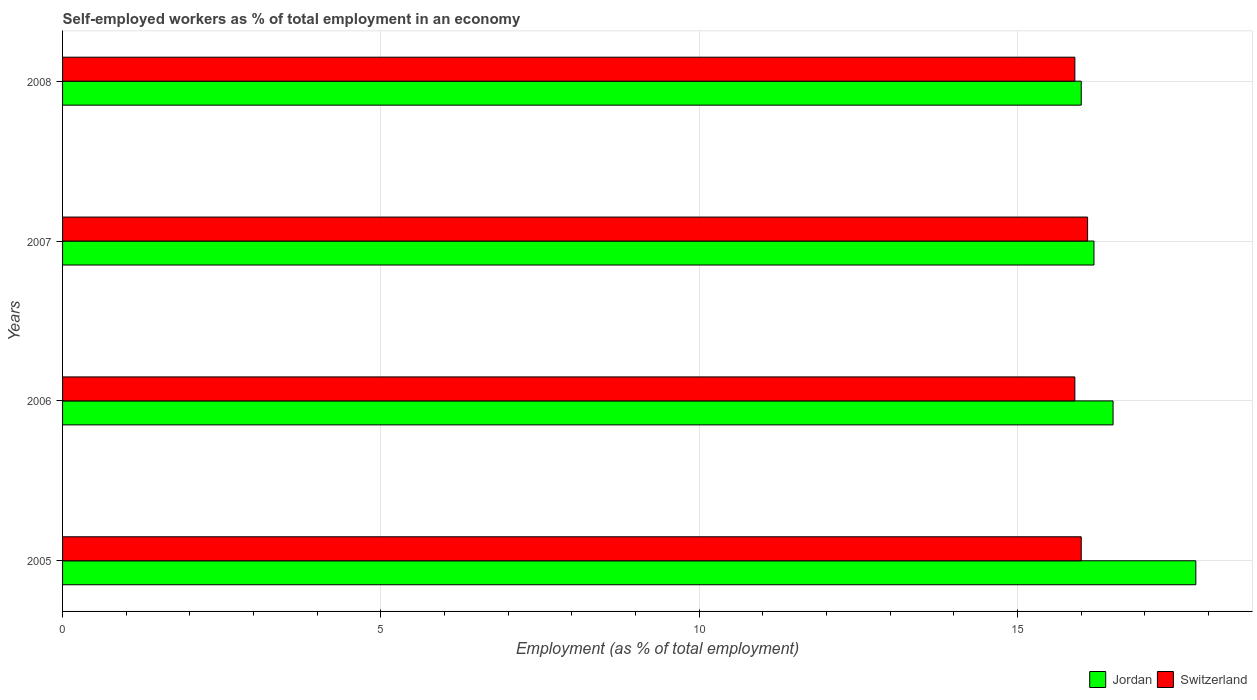Are the number of bars per tick equal to the number of legend labels?
Your response must be concise. Yes. Are the number of bars on each tick of the Y-axis equal?
Your answer should be very brief. Yes. How many bars are there on the 2nd tick from the top?
Your answer should be compact. 2. How many bars are there on the 3rd tick from the bottom?
Provide a short and direct response. 2. What is the percentage of self-employed workers in Switzerland in 2006?
Your answer should be compact. 15.9. Across all years, what is the maximum percentage of self-employed workers in Switzerland?
Keep it short and to the point. 16.1. In which year was the percentage of self-employed workers in Jordan maximum?
Offer a terse response. 2005. What is the total percentage of self-employed workers in Switzerland in the graph?
Ensure brevity in your answer.  63.9. What is the difference between the percentage of self-employed workers in Jordan in 2005 and that in 2006?
Provide a short and direct response. 1.3. What is the difference between the percentage of self-employed workers in Switzerland in 2006 and the percentage of self-employed workers in Jordan in 2005?
Offer a very short reply. -1.9. What is the average percentage of self-employed workers in Jordan per year?
Provide a short and direct response. 16.62. In the year 2008, what is the difference between the percentage of self-employed workers in Switzerland and percentage of self-employed workers in Jordan?
Make the answer very short. -0.1. What is the ratio of the percentage of self-employed workers in Switzerland in 2005 to that in 2007?
Ensure brevity in your answer.  0.99. Is the percentage of self-employed workers in Switzerland in 2005 less than that in 2006?
Your response must be concise. No. Is the difference between the percentage of self-employed workers in Switzerland in 2005 and 2008 greater than the difference between the percentage of self-employed workers in Jordan in 2005 and 2008?
Offer a very short reply. No. What is the difference between the highest and the second highest percentage of self-employed workers in Jordan?
Your response must be concise. 1.3. What is the difference between the highest and the lowest percentage of self-employed workers in Jordan?
Your answer should be very brief. 1.8. In how many years, is the percentage of self-employed workers in Jordan greater than the average percentage of self-employed workers in Jordan taken over all years?
Ensure brevity in your answer.  1. What does the 2nd bar from the top in 2008 represents?
Your answer should be very brief. Jordan. What does the 2nd bar from the bottom in 2005 represents?
Provide a short and direct response. Switzerland. How many bars are there?
Your answer should be very brief. 8. How many years are there in the graph?
Offer a very short reply. 4. What is the difference between two consecutive major ticks on the X-axis?
Keep it short and to the point. 5. Does the graph contain any zero values?
Make the answer very short. No. Does the graph contain grids?
Your answer should be compact. Yes. How many legend labels are there?
Offer a very short reply. 2. What is the title of the graph?
Keep it short and to the point. Self-employed workers as % of total employment in an economy. Does "Colombia" appear as one of the legend labels in the graph?
Provide a short and direct response. No. What is the label or title of the X-axis?
Ensure brevity in your answer.  Employment (as % of total employment). What is the Employment (as % of total employment) in Jordan in 2005?
Provide a succinct answer. 17.8. What is the Employment (as % of total employment) of Switzerland in 2005?
Ensure brevity in your answer.  16. What is the Employment (as % of total employment) in Jordan in 2006?
Provide a short and direct response. 16.5. What is the Employment (as % of total employment) of Switzerland in 2006?
Your answer should be compact. 15.9. What is the Employment (as % of total employment) of Jordan in 2007?
Offer a very short reply. 16.2. What is the Employment (as % of total employment) in Switzerland in 2007?
Give a very brief answer. 16.1. What is the Employment (as % of total employment) in Jordan in 2008?
Your answer should be very brief. 16. What is the Employment (as % of total employment) of Switzerland in 2008?
Give a very brief answer. 15.9. Across all years, what is the maximum Employment (as % of total employment) of Jordan?
Your answer should be very brief. 17.8. Across all years, what is the maximum Employment (as % of total employment) of Switzerland?
Offer a very short reply. 16.1. Across all years, what is the minimum Employment (as % of total employment) of Switzerland?
Provide a succinct answer. 15.9. What is the total Employment (as % of total employment) of Jordan in the graph?
Provide a short and direct response. 66.5. What is the total Employment (as % of total employment) in Switzerland in the graph?
Provide a short and direct response. 63.9. What is the difference between the Employment (as % of total employment) of Jordan in 2005 and that in 2006?
Provide a succinct answer. 1.3. What is the difference between the Employment (as % of total employment) in Switzerland in 2005 and that in 2007?
Make the answer very short. -0.1. What is the difference between the Employment (as % of total employment) of Jordan in 2006 and that in 2007?
Offer a very short reply. 0.3. What is the difference between the Employment (as % of total employment) of Switzerland in 2006 and that in 2007?
Make the answer very short. -0.2. What is the difference between the Employment (as % of total employment) in Jordan in 2006 and that in 2008?
Offer a terse response. 0.5. What is the difference between the Employment (as % of total employment) of Jordan in 2007 and that in 2008?
Provide a short and direct response. 0.2. What is the difference between the Employment (as % of total employment) in Switzerland in 2007 and that in 2008?
Provide a succinct answer. 0.2. What is the difference between the Employment (as % of total employment) in Jordan in 2005 and the Employment (as % of total employment) in Switzerland in 2007?
Make the answer very short. 1.7. What is the difference between the Employment (as % of total employment) in Jordan in 2006 and the Employment (as % of total employment) in Switzerland in 2007?
Make the answer very short. 0.4. What is the difference between the Employment (as % of total employment) of Jordan in 2006 and the Employment (as % of total employment) of Switzerland in 2008?
Ensure brevity in your answer.  0.6. What is the average Employment (as % of total employment) of Jordan per year?
Offer a very short reply. 16.62. What is the average Employment (as % of total employment) in Switzerland per year?
Offer a terse response. 15.97. In the year 2008, what is the difference between the Employment (as % of total employment) of Jordan and Employment (as % of total employment) of Switzerland?
Provide a succinct answer. 0.1. What is the ratio of the Employment (as % of total employment) in Jordan in 2005 to that in 2006?
Provide a short and direct response. 1.08. What is the ratio of the Employment (as % of total employment) of Switzerland in 2005 to that in 2006?
Offer a very short reply. 1.01. What is the ratio of the Employment (as % of total employment) of Jordan in 2005 to that in 2007?
Give a very brief answer. 1.1. What is the ratio of the Employment (as % of total employment) of Jordan in 2005 to that in 2008?
Your answer should be compact. 1.11. What is the ratio of the Employment (as % of total employment) of Switzerland in 2005 to that in 2008?
Your answer should be compact. 1.01. What is the ratio of the Employment (as % of total employment) of Jordan in 2006 to that in 2007?
Your answer should be very brief. 1.02. What is the ratio of the Employment (as % of total employment) in Switzerland in 2006 to that in 2007?
Offer a terse response. 0.99. What is the ratio of the Employment (as % of total employment) in Jordan in 2006 to that in 2008?
Offer a terse response. 1.03. What is the ratio of the Employment (as % of total employment) in Jordan in 2007 to that in 2008?
Your response must be concise. 1.01. What is the ratio of the Employment (as % of total employment) of Switzerland in 2007 to that in 2008?
Ensure brevity in your answer.  1.01. What is the difference between the highest and the second highest Employment (as % of total employment) in Jordan?
Your answer should be very brief. 1.3. What is the difference between the highest and the second highest Employment (as % of total employment) in Switzerland?
Make the answer very short. 0.1. What is the difference between the highest and the lowest Employment (as % of total employment) of Jordan?
Give a very brief answer. 1.8. 